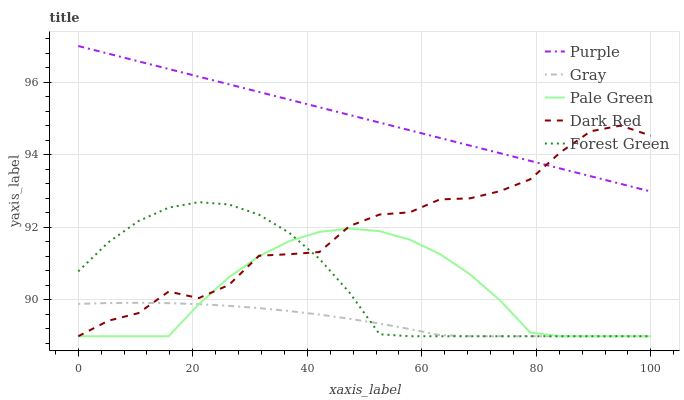Does Gray have the minimum area under the curve?
Answer yes or no. Yes. Does Purple have the maximum area under the curve?
Answer yes or no. Yes. Does Forest Green have the minimum area under the curve?
Answer yes or no. No. Does Forest Green have the maximum area under the curve?
Answer yes or no. No. Is Purple the smoothest?
Answer yes or no. Yes. Is Dark Red the roughest?
Answer yes or no. Yes. Is Gray the smoothest?
Answer yes or no. No. Is Gray the roughest?
Answer yes or no. No. Does Gray have the lowest value?
Answer yes or no. Yes. Does Purple have the highest value?
Answer yes or no. Yes. Does Forest Green have the highest value?
Answer yes or no. No. Is Gray less than Purple?
Answer yes or no. Yes. Is Purple greater than Gray?
Answer yes or no. Yes. Does Forest Green intersect Pale Green?
Answer yes or no. Yes. Is Forest Green less than Pale Green?
Answer yes or no. No. Is Forest Green greater than Pale Green?
Answer yes or no. No. Does Gray intersect Purple?
Answer yes or no. No. 